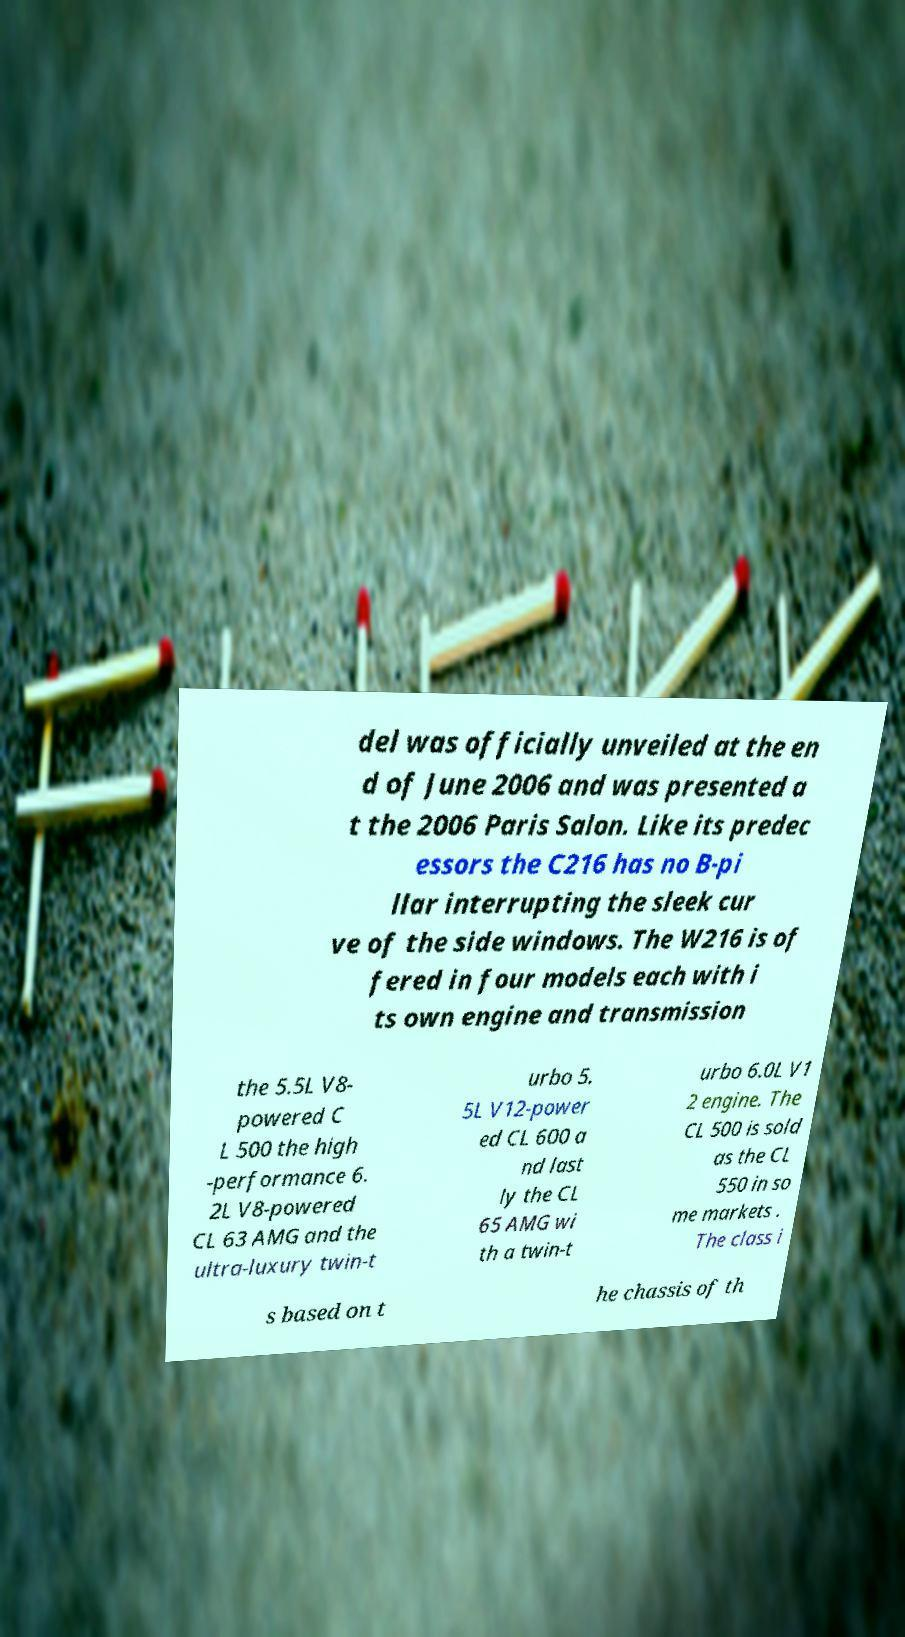Please identify and transcribe the text found in this image. del was officially unveiled at the en d of June 2006 and was presented a t the 2006 Paris Salon. Like its predec essors the C216 has no B-pi llar interrupting the sleek cur ve of the side windows. The W216 is of fered in four models each with i ts own engine and transmission the 5.5L V8- powered C L 500 the high -performance 6. 2L V8-powered CL 63 AMG and the ultra-luxury twin-t urbo 5. 5L V12-power ed CL 600 a nd last ly the CL 65 AMG wi th a twin-t urbo 6.0L V1 2 engine. The CL 500 is sold as the CL 550 in so me markets . The class i s based on t he chassis of th 